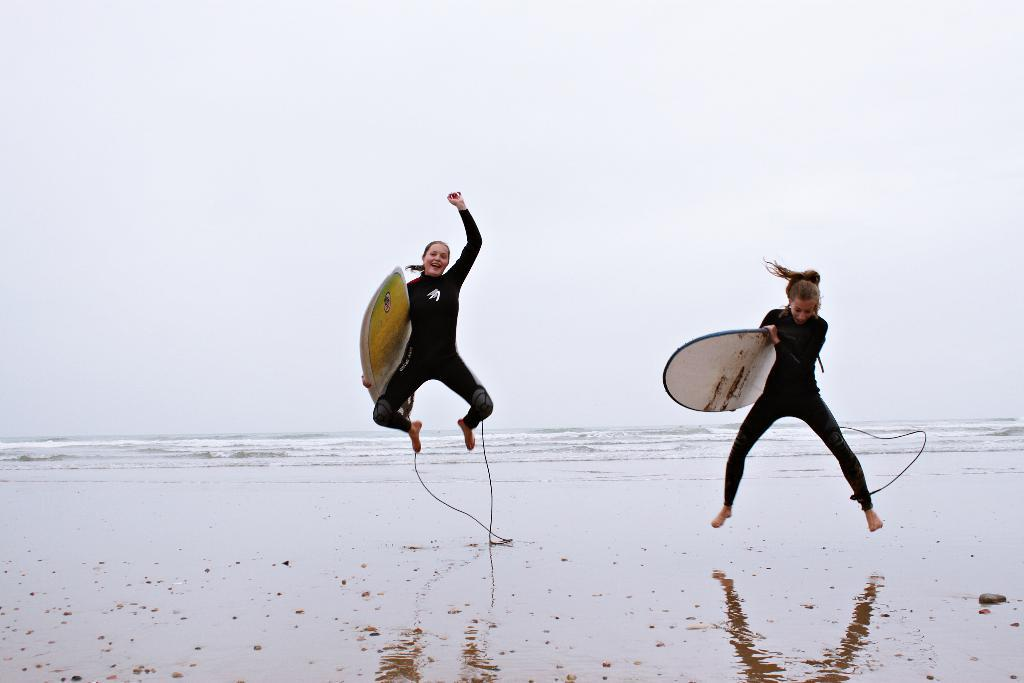How many people are in the image? There are two people in the image. What are the people holding in the image? The people are holding surfing boards. What can be seen in the background of the image? There is an ocean in the background of the image. What is the condition of the sky in the image? The sky is clear in the image. Can you tell me how many donkeys are present in the image? There are no donkeys present in the image. What type of side dish is being exchanged between the two people in the image? There is no exchange of any side dish or food item visible in the image. 